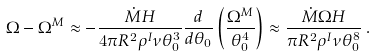Convert formula to latex. <formula><loc_0><loc_0><loc_500><loc_500>\Omega - \Omega ^ { M } \approx - \frac { { \dot { M } } H } { 4 \pi R ^ { 2 } \rho ^ { I } \nu \theta _ { 0 } ^ { 3 } } \frac { d } { d \theta _ { 0 } } \left ( \frac { \Omega ^ { M } } { \theta _ { 0 } ^ { 4 } } \right ) \approx \frac { { \dot { M } } \Omega H } { \pi R ^ { 2 } \rho ^ { I } \nu \theta _ { 0 } ^ { 8 } } \, .</formula> 